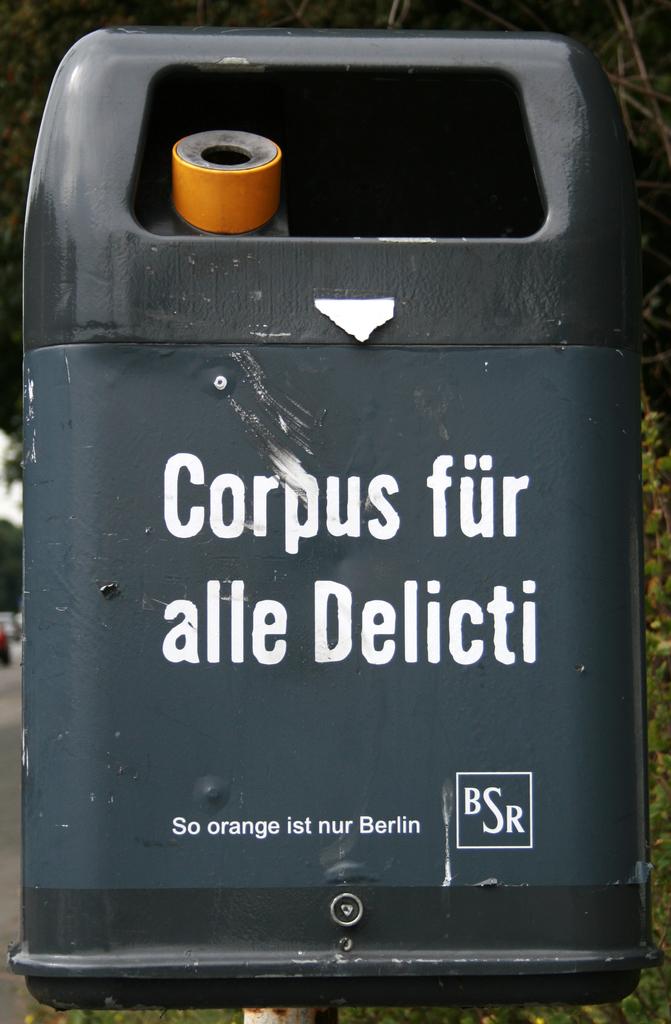What fruit is mentioned on this object?
Your response must be concise. Orange. Which city is the trashcan in?
Ensure brevity in your answer.  Berlin. 